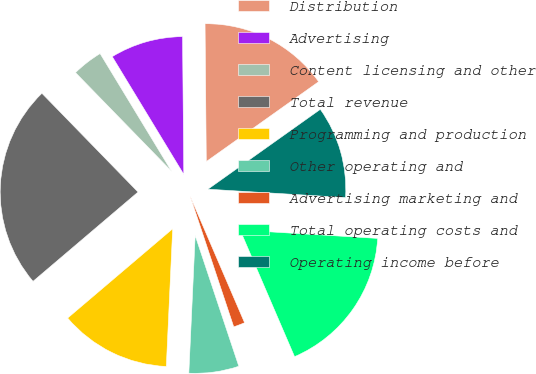Convert chart. <chart><loc_0><loc_0><loc_500><loc_500><pie_chart><fcel>Distribution<fcel>Advertising<fcel>Content licensing and other<fcel>Total revenue<fcel>Programming and production<fcel>Other operating and<fcel>Advertising marketing and<fcel>Total operating costs and<fcel>Operating income before<nl><fcel>15.31%<fcel>8.54%<fcel>3.6%<fcel>23.93%<fcel>13.05%<fcel>5.86%<fcel>1.34%<fcel>17.57%<fcel>10.8%<nl></chart> 